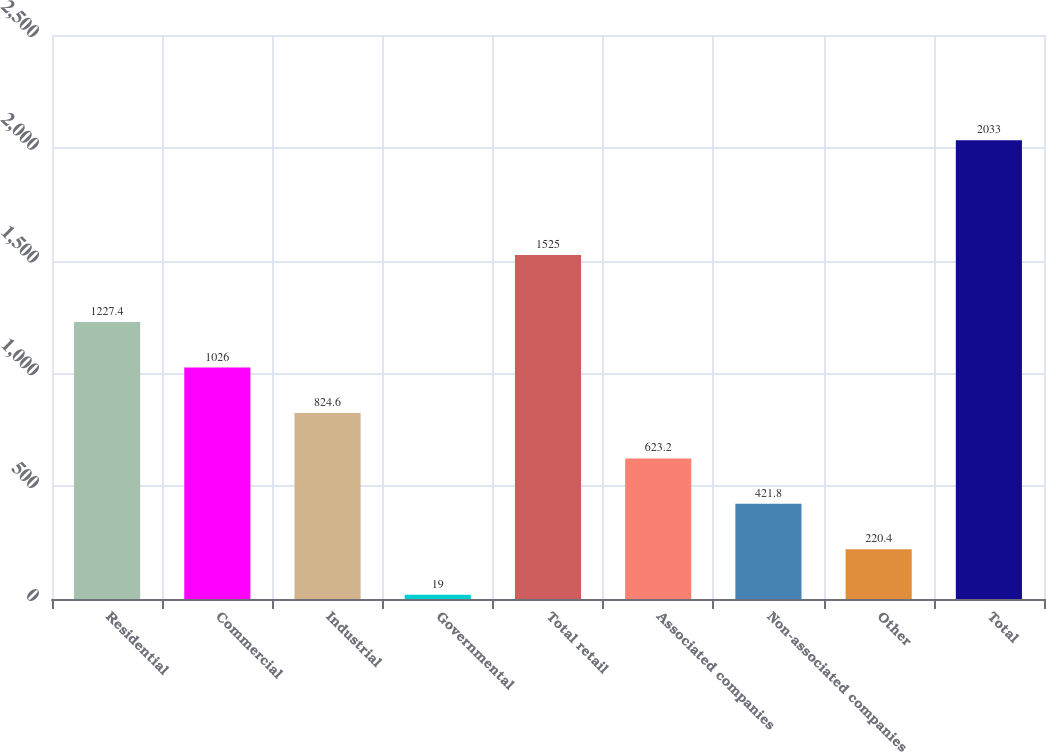Convert chart to OTSL. <chart><loc_0><loc_0><loc_500><loc_500><bar_chart><fcel>Residential<fcel>Commercial<fcel>Industrial<fcel>Governmental<fcel>Total retail<fcel>Associated companies<fcel>Non-associated companies<fcel>Other<fcel>Total<nl><fcel>1227.4<fcel>1026<fcel>824.6<fcel>19<fcel>1525<fcel>623.2<fcel>421.8<fcel>220.4<fcel>2033<nl></chart> 